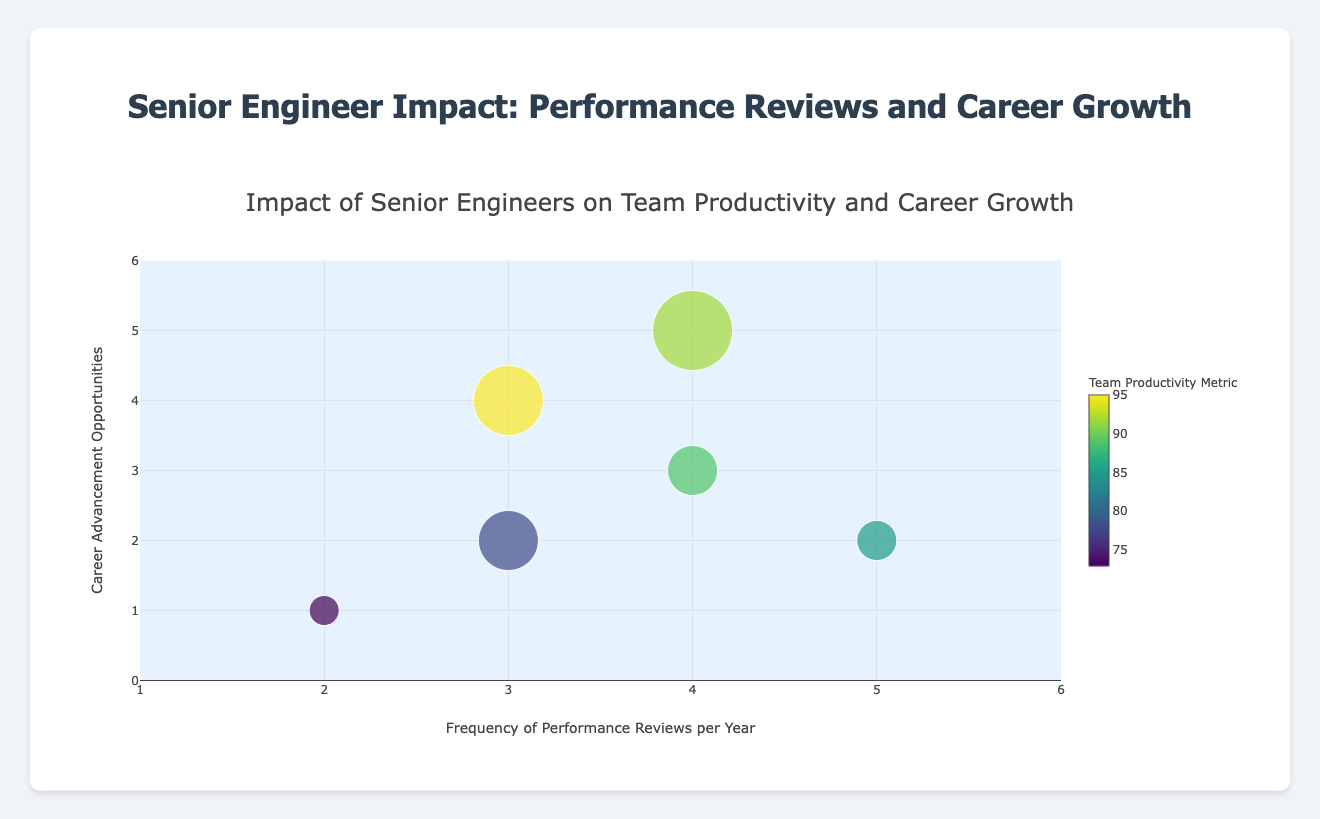How many companies are represented in the figure? The figure represents data for each company in a bubble, and there are six companies listed: Tech Innovators Inc., Future Systems Ltd., Quantum Solutions, Nebula Tech Corp., Pioneer Tech Co., and FutureGen Robotics
Answer: 6 Which company has the highest team productivity metric? The team productivity metric is indicated by the color of the bubble. The company with the highest value on the color scale (brightest color) is Quantum Solutions with a productivity metric of 95
Answer: Quantum Solutions What is the relationship between the frequency of performance reviews and the career advancement opportunities at Nebula Tech Corp.? Nebula Tech Corp. is plotted where the frequency of reviews is 5 and career advancement opportunities are 2, reflecting that they have a high frequency of reviews but fewer career opportunities
Answer: Nebula Tech Corp. has a high frequency of reviews but fewer career opportunities Compare the number of senior engineers at Future Systems Ltd. and FutureGen Robotics. Look at the bubble sizes which represent the number of senior engineers. Future Systems Ltd. has 3 senior engineers, and FutureGen Robotics has 8 senior engineers, indicating FutureGen Robotics has more than twice as many senior engineers
Answer: FutureGen Robotics has more senior engineers Which company has the most balance between high frequency of reviews and career advancement opportunities? The balance can be interpreted from the figure as proximity to the upper-right corner of the plot. FutureGen Robotics, with 4 reviews/year and 5 advancement opportunities, is closest to this quadrant
Answer: FutureGen Robotics What is the average frequency of performance reviews per year for all companies? Sum the review frequencies from all companies (4+2+3+5+3+4 = 21) and divide by the number of companies (6). The average is 21/6
Answer: 3.5 What bubble color would represent medium team productivity, and which company matches this color? Medium productivity would fall in the middle of the color range. Tech Innovators Inc., with a productivity metric of 89, should exhibit a medium color intensity on the Viridis scale
Answer: Tech Innovators Inc Which company has the least number of career advancement opportunities and what's their team productivity metric? The least number of career opportunities is 1, corresponding to Future Systems Ltd, which has a team productivity metric of 73
Answer: Future Systems Ltd. with a productivity metric of 73 What can you infer about the relationship between senior engineers and team productivity from the figure? The bubble sizes indicating more senior engineers, such as Quantum Solutions and FutureGen Robotics, also have higher productivity metrics. This suggests a positive correlation between the number of senior engineers and team productivity
Answer: Positive correlation 